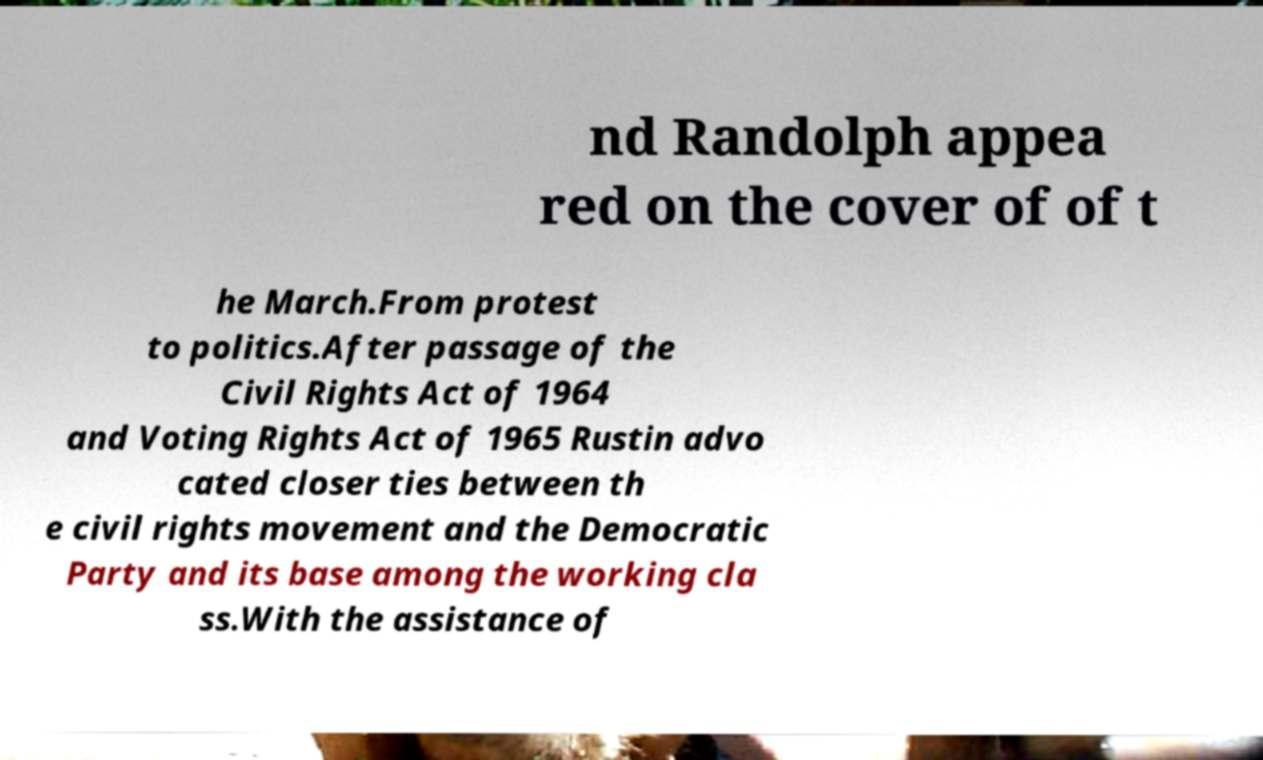Can you read and provide the text displayed in the image?This photo seems to have some interesting text. Can you extract and type it out for me? nd Randolph appea red on the cover of of t he March.From protest to politics.After passage of the Civil Rights Act of 1964 and Voting Rights Act of 1965 Rustin advo cated closer ties between th e civil rights movement and the Democratic Party and its base among the working cla ss.With the assistance of 